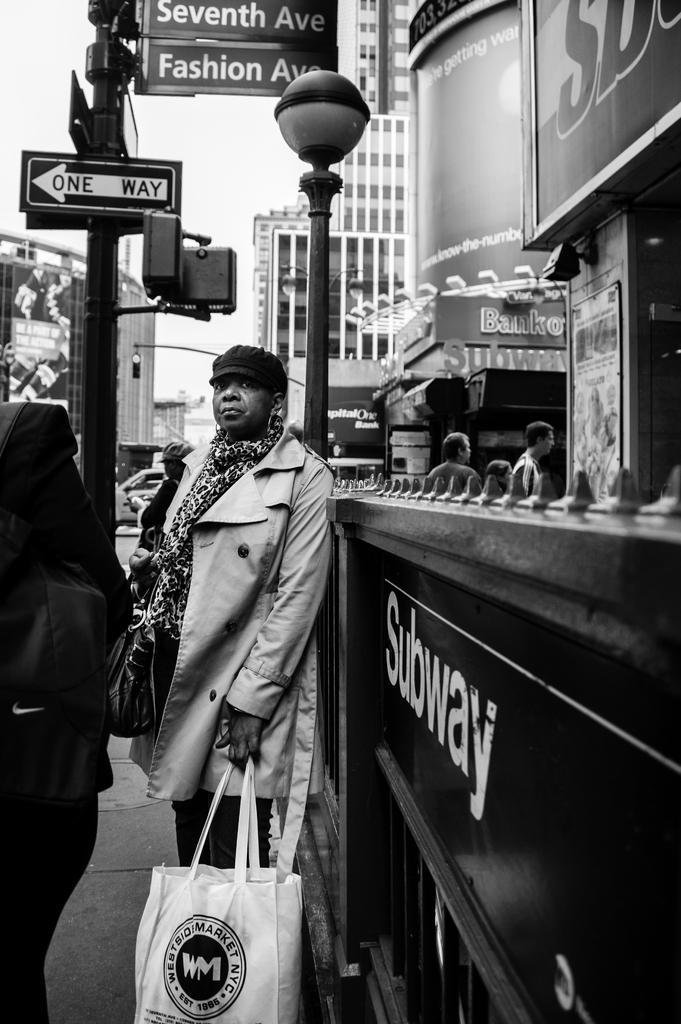Describe this image in one or two sentences. In this image I see a woman who is standing and holding a bag in her hand, In the background I see boards on the pole and buildings and few people over here. 